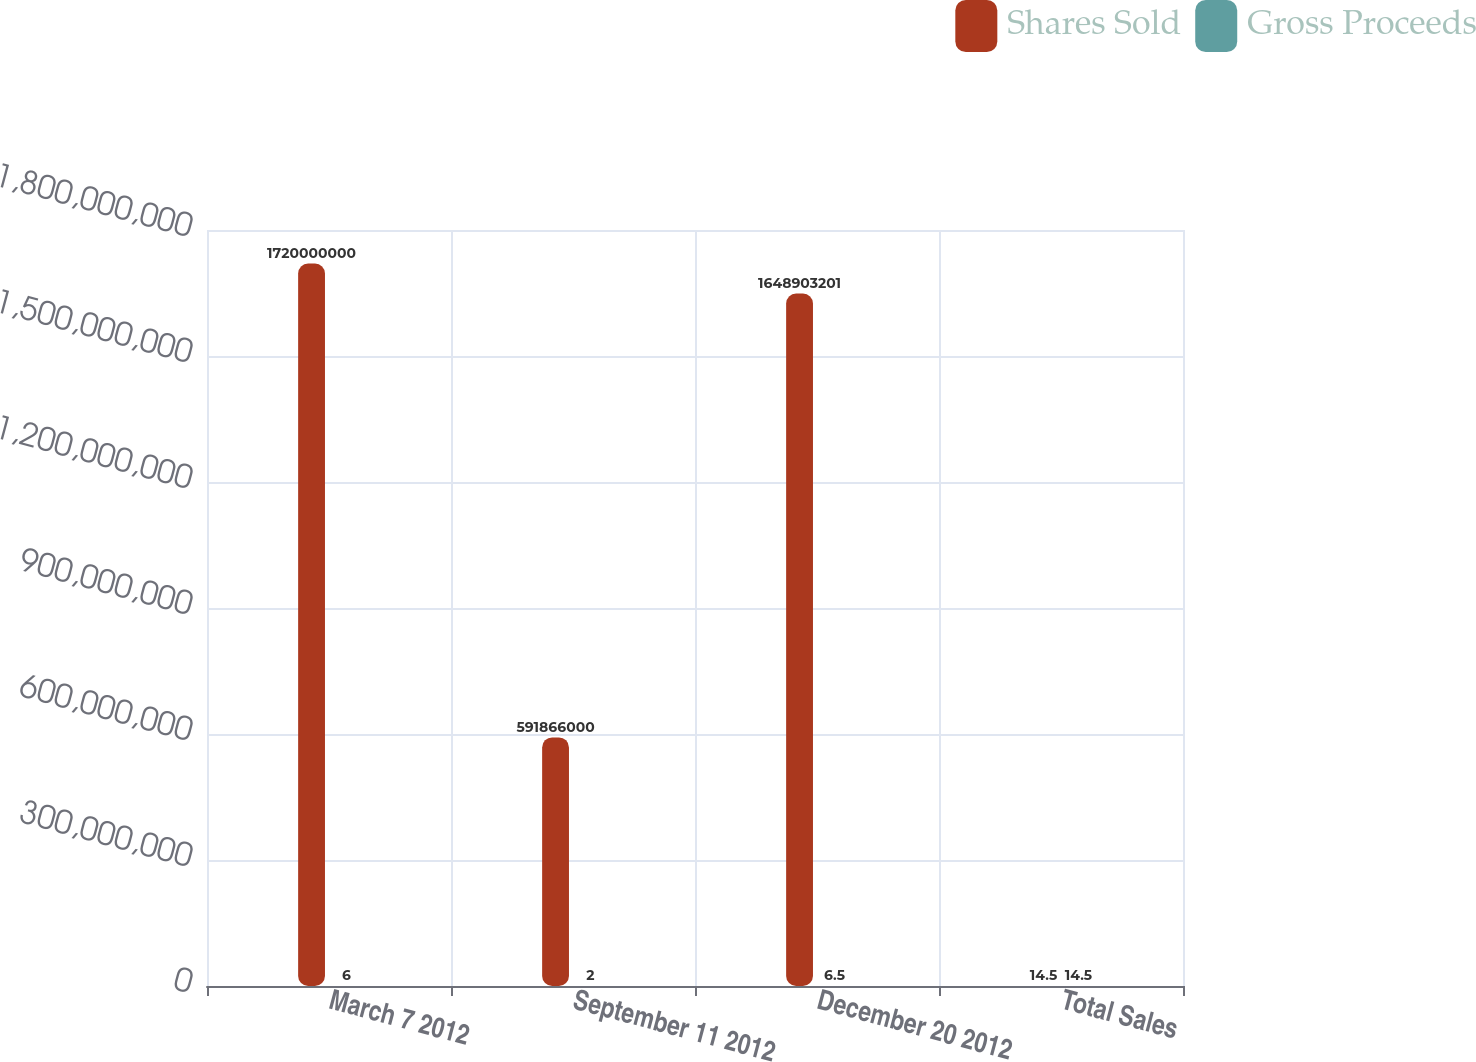Convert chart. <chart><loc_0><loc_0><loc_500><loc_500><stacked_bar_chart><ecel><fcel>March 7 2012<fcel>September 11 2012<fcel>December 20 2012<fcel>Total Sales<nl><fcel>Shares Sold<fcel>1.72e+09<fcel>5.91866e+08<fcel>1.6489e+09<fcel>14.5<nl><fcel>Gross Proceeds<fcel>6<fcel>2<fcel>6.5<fcel>14.5<nl></chart> 